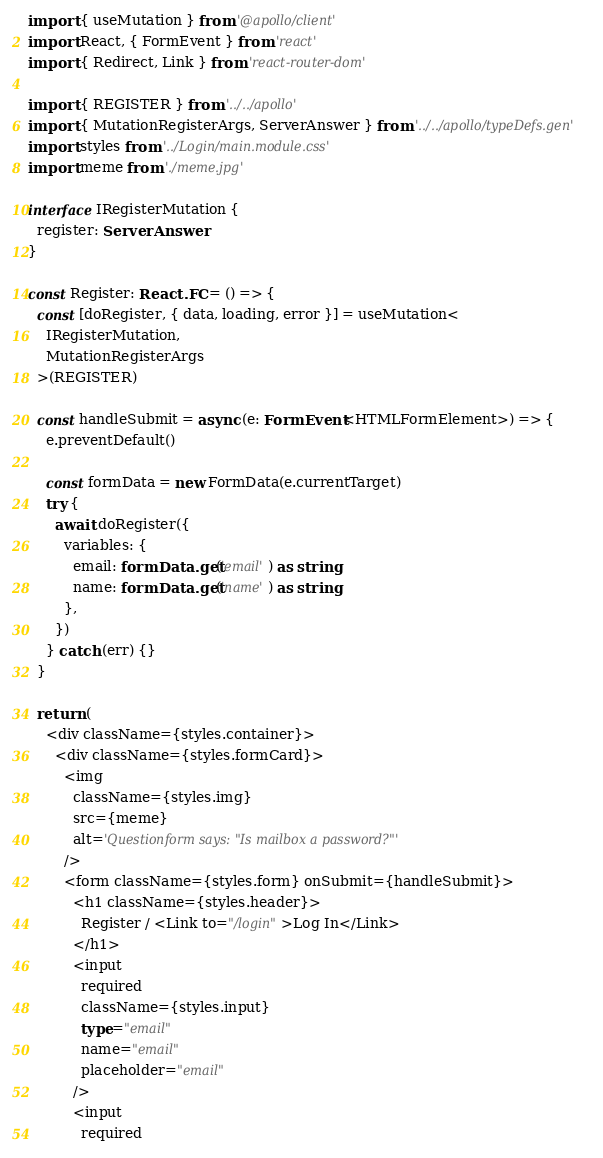<code> <loc_0><loc_0><loc_500><loc_500><_TypeScript_>import { useMutation } from '@apollo/client'
import React, { FormEvent } from 'react'
import { Redirect, Link } from 'react-router-dom'

import { REGISTER } from '../../apollo'
import { MutationRegisterArgs, ServerAnswer } from '../../apollo/typeDefs.gen'
import styles from '../Login/main.module.css'
import meme from './meme.jpg'

interface IRegisterMutation {
  register: ServerAnswer
}

const Register: React.FC = () => {
  const [doRegister, { data, loading, error }] = useMutation<
    IRegisterMutation,
    MutationRegisterArgs
  >(REGISTER)

  const handleSubmit = async (e: FormEvent<HTMLFormElement>) => {
    e.preventDefault()

    const formData = new FormData(e.currentTarget)
    try {
      await doRegister({
        variables: {
          email: formData.get('email') as string,
          name: formData.get('name') as string,
        },
      })
    } catch (err) {}
  }

  return (
    <div className={styles.container}>
      <div className={styles.formCard}>
        <img
          className={styles.img}
          src={meme}
          alt='Questionform says: "Is mailbox a password?"'
        />
        <form className={styles.form} onSubmit={handleSubmit}>
          <h1 className={styles.header}>
            Register / <Link to="/login">Log In</Link>
          </h1>
          <input
            required
            className={styles.input}
            type="email"
            name="email"
            placeholder="email"
          />
          <input
            required</code> 